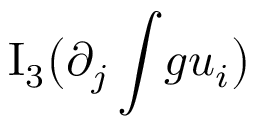Convert formula to latex. <formula><loc_0><loc_0><loc_500><loc_500>I _ { 3 } \left ( \partial _ { j } \int \, g u _ { i } \right )</formula> 